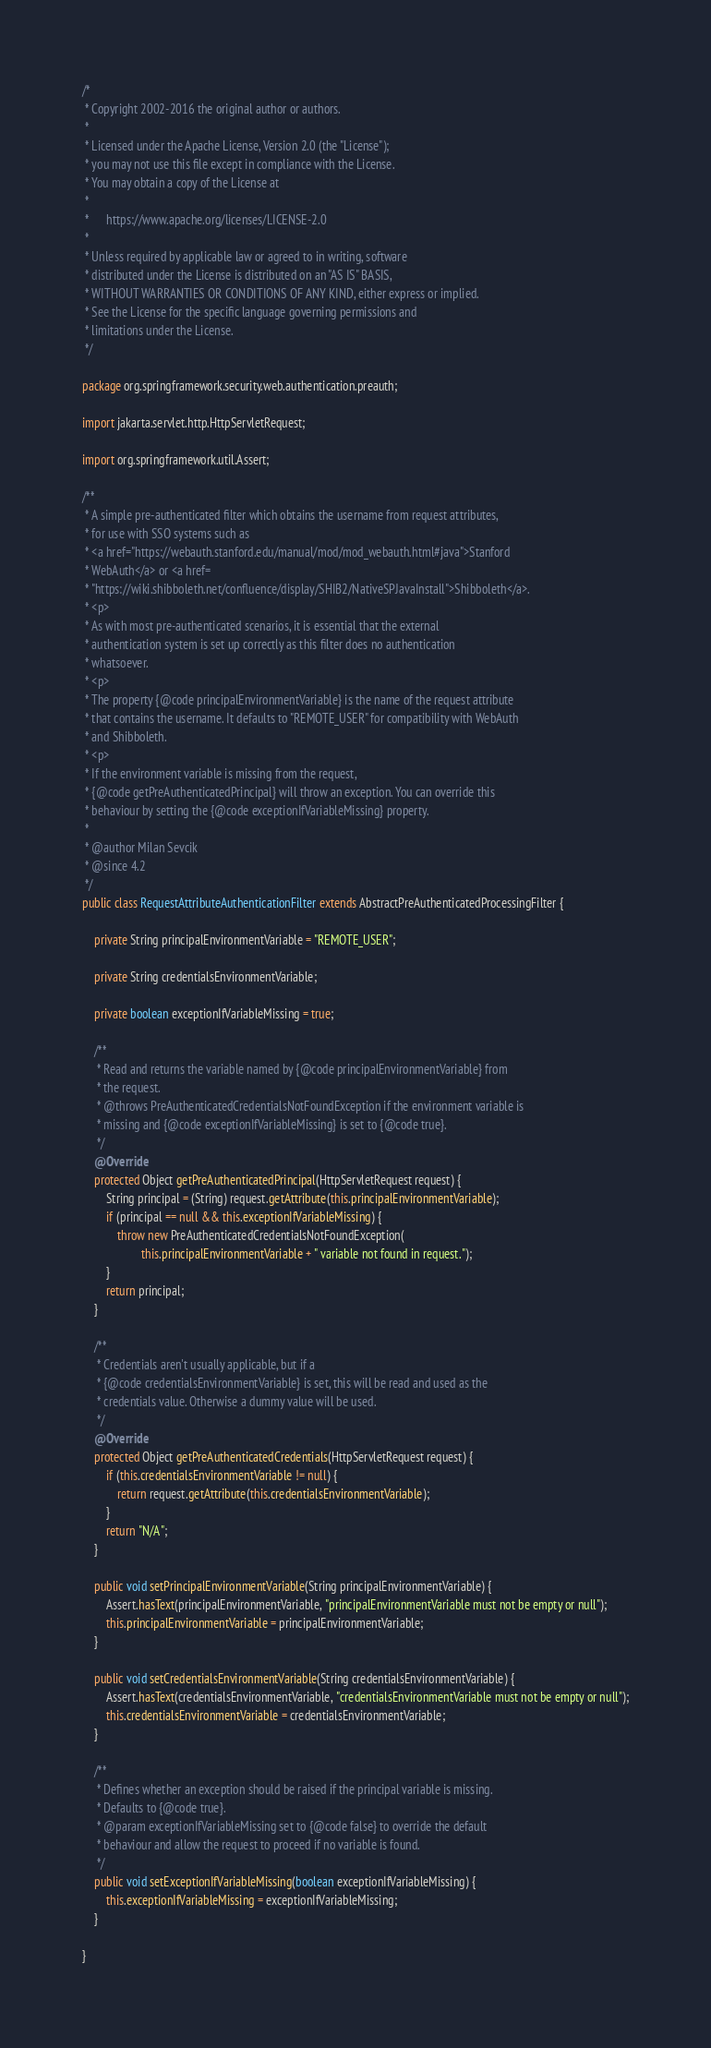<code> <loc_0><loc_0><loc_500><loc_500><_Java_>/*
 * Copyright 2002-2016 the original author or authors.
 *
 * Licensed under the Apache License, Version 2.0 (the "License");
 * you may not use this file except in compliance with the License.
 * You may obtain a copy of the License at
 *
 *      https://www.apache.org/licenses/LICENSE-2.0
 *
 * Unless required by applicable law or agreed to in writing, software
 * distributed under the License is distributed on an "AS IS" BASIS,
 * WITHOUT WARRANTIES OR CONDITIONS OF ANY KIND, either express or implied.
 * See the License for the specific language governing permissions and
 * limitations under the License.
 */

package org.springframework.security.web.authentication.preauth;

import jakarta.servlet.http.HttpServletRequest;

import org.springframework.util.Assert;

/**
 * A simple pre-authenticated filter which obtains the username from request attributes,
 * for use with SSO systems such as
 * <a href="https://webauth.stanford.edu/manual/mod/mod_webauth.html#java">Stanford
 * WebAuth</a> or <a href=
 * "https://wiki.shibboleth.net/confluence/display/SHIB2/NativeSPJavaInstall">Shibboleth</a>.
 * <p>
 * As with most pre-authenticated scenarios, it is essential that the external
 * authentication system is set up correctly as this filter does no authentication
 * whatsoever.
 * <p>
 * The property {@code principalEnvironmentVariable} is the name of the request attribute
 * that contains the username. It defaults to "REMOTE_USER" for compatibility with WebAuth
 * and Shibboleth.
 * <p>
 * If the environment variable is missing from the request,
 * {@code getPreAuthenticatedPrincipal} will throw an exception. You can override this
 * behaviour by setting the {@code exceptionIfVariableMissing} property.
 *
 * @author Milan Sevcik
 * @since 4.2
 */
public class RequestAttributeAuthenticationFilter extends AbstractPreAuthenticatedProcessingFilter {

	private String principalEnvironmentVariable = "REMOTE_USER";

	private String credentialsEnvironmentVariable;

	private boolean exceptionIfVariableMissing = true;

	/**
	 * Read and returns the variable named by {@code principalEnvironmentVariable} from
	 * the request.
	 * @throws PreAuthenticatedCredentialsNotFoundException if the environment variable is
	 * missing and {@code exceptionIfVariableMissing} is set to {@code true}.
	 */
	@Override
	protected Object getPreAuthenticatedPrincipal(HttpServletRequest request) {
		String principal = (String) request.getAttribute(this.principalEnvironmentVariable);
		if (principal == null && this.exceptionIfVariableMissing) {
			throw new PreAuthenticatedCredentialsNotFoundException(
					this.principalEnvironmentVariable + " variable not found in request.");
		}
		return principal;
	}

	/**
	 * Credentials aren't usually applicable, but if a
	 * {@code credentialsEnvironmentVariable} is set, this will be read and used as the
	 * credentials value. Otherwise a dummy value will be used.
	 */
	@Override
	protected Object getPreAuthenticatedCredentials(HttpServletRequest request) {
		if (this.credentialsEnvironmentVariable != null) {
			return request.getAttribute(this.credentialsEnvironmentVariable);
		}
		return "N/A";
	}

	public void setPrincipalEnvironmentVariable(String principalEnvironmentVariable) {
		Assert.hasText(principalEnvironmentVariable, "principalEnvironmentVariable must not be empty or null");
		this.principalEnvironmentVariable = principalEnvironmentVariable;
	}

	public void setCredentialsEnvironmentVariable(String credentialsEnvironmentVariable) {
		Assert.hasText(credentialsEnvironmentVariable, "credentialsEnvironmentVariable must not be empty or null");
		this.credentialsEnvironmentVariable = credentialsEnvironmentVariable;
	}

	/**
	 * Defines whether an exception should be raised if the principal variable is missing.
	 * Defaults to {@code true}.
	 * @param exceptionIfVariableMissing set to {@code false} to override the default
	 * behaviour and allow the request to proceed if no variable is found.
	 */
	public void setExceptionIfVariableMissing(boolean exceptionIfVariableMissing) {
		this.exceptionIfVariableMissing = exceptionIfVariableMissing;
	}

}
</code> 